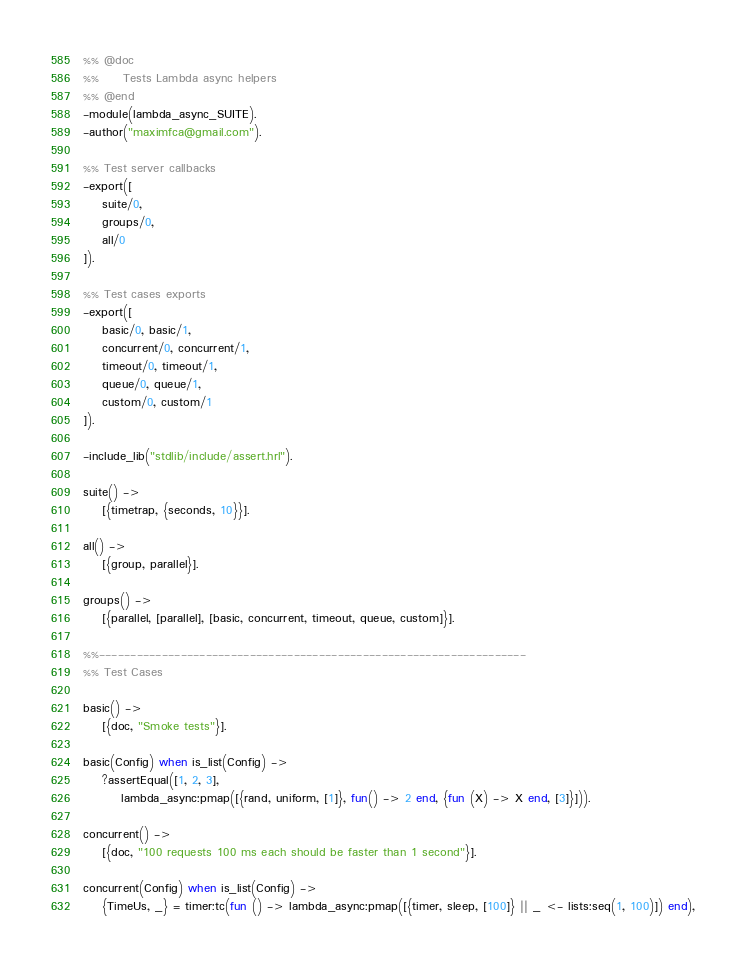<code> <loc_0><loc_0><loc_500><loc_500><_Erlang_>%% @doc
%%     Tests Lambda async helpers
%% @end
-module(lambda_async_SUITE).
-author("maximfca@gmail.com").

%% Test server callbacks
-export([
    suite/0,
    groups/0,
    all/0
]).

%% Test cases exports
-export([
    basic/0, basic/1,
    concurrent/0, concurrent/1,
    timeout/0, timeout/1,
    queue/0, queue/1,
    custom/0, custom/1
]).

-include_lib("stdlib/include/assert.hrl").

suite() ->
    [{timetrap, {seconds, 10}}].

all() ->
    [{group, parallel}].

groups() ->
    [{parallel, [parallel], [basic, concurrent, timeout, queue, custom]}].

%%--------------------------------------------------------------------
%% Test Cases

basic() ->
    [{doc, "Smoke tests"}].

basic(Config) when is_list(Config) ->
    ?assertEqual([1, 2, 3],
        lambda_async:pmap([{rand, uniform, [1]}, fun() -> 2 end, {fun (X) -> X end, [3]}])).

concurrent() ->
    [{doc, "100 requests 100 ms each should be faster than 1 second"}].

concurrent(Config) when is_list(Config) ->
    {TimeUs, _} = timer:tc(fun () -> lambda_async:pmap([{timer, sleep, [100]} || _ <- lists:seq(1, 100)]) end),</code> 